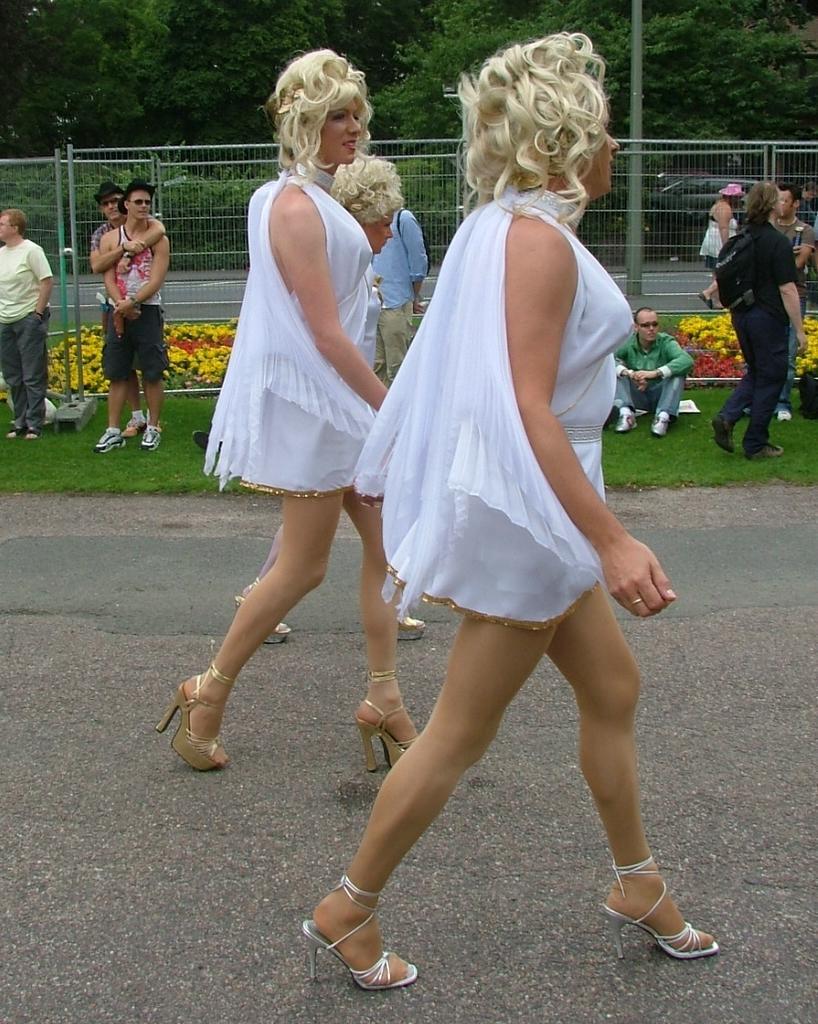How would you summarize this image in a sentence or two? In this picture there is a woman who is wearing white dress and sandals. They are walking on the road. In the background we can see the group of person standing near to the fencing and the flowers. At the top we can see many trees and pole. 